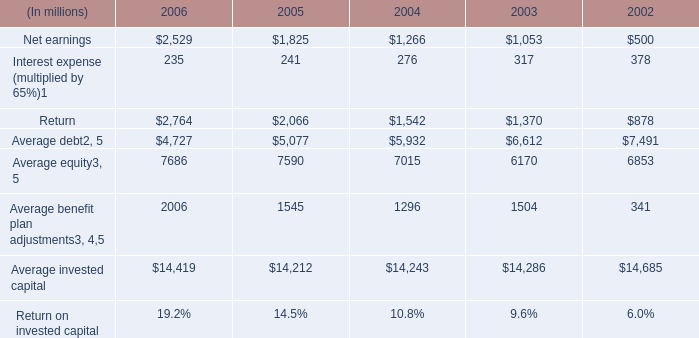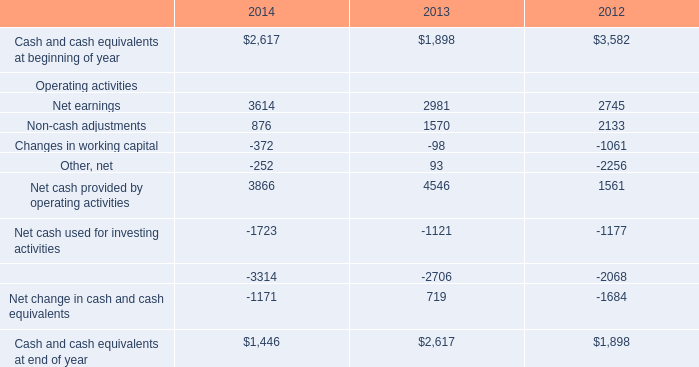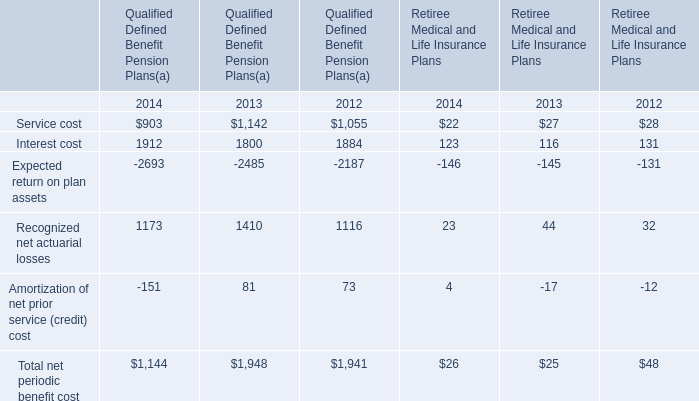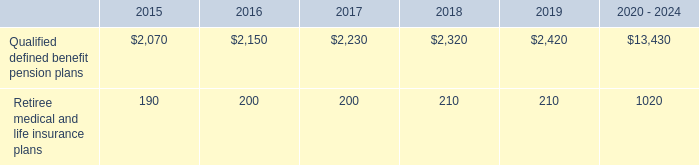What's the sum of the Interest cost for Qualified Defined Benefit Pension Plans(a) in the years where Net earnings for Operating activities is greater than 0? 
Computations: ((1912 + 1800) + 1884)
Answer: 5596.0. 